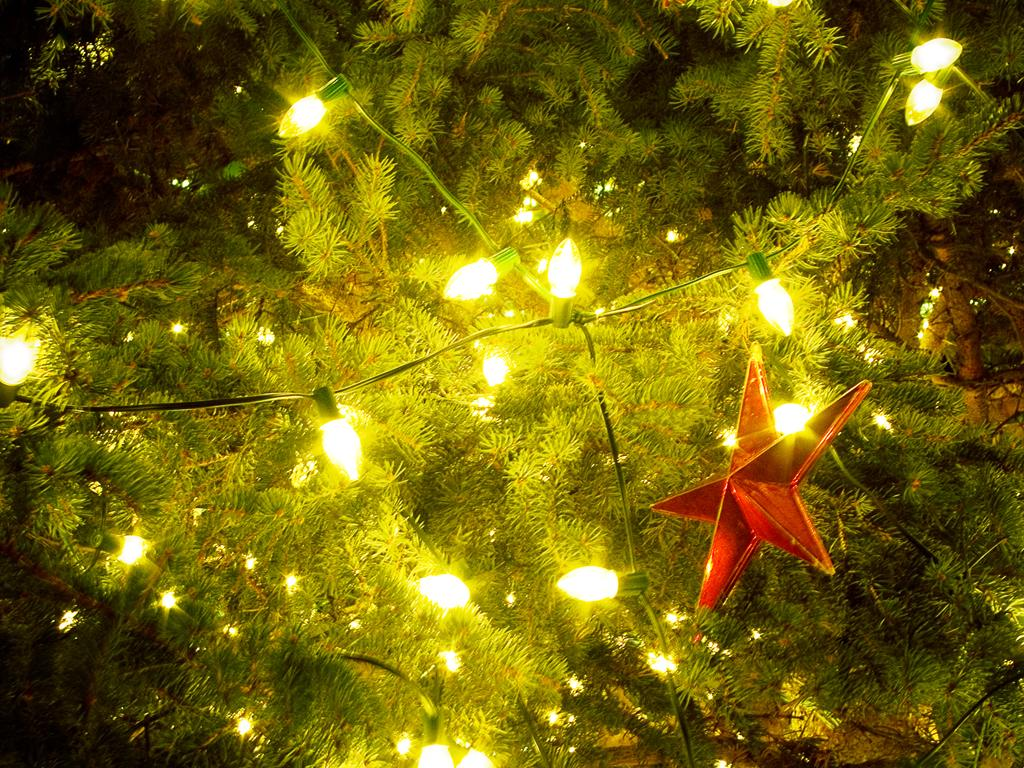What type of tree is featured in the image? There is a Christmas tree in the image. What decoration is placed at the top of the Christmas tree? There is a star on the Christmas tree. What type of lights are present on the Christmas tree? Serial lights are present on the Christmas tree. How do the geese sense the Christmas tree in the image? There are no geese present in the image, so it is not possible to determine how they might sense the Christmas tree. 